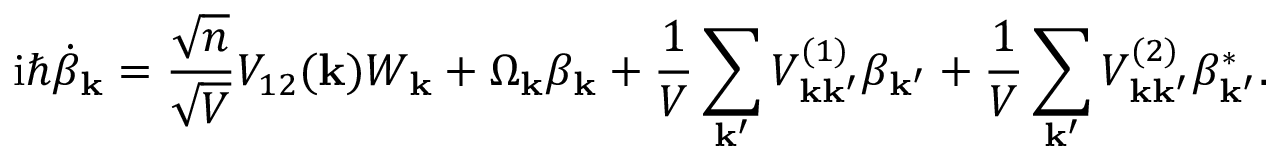Convert formula to latex. <formula><loc_0><loc_0><loc_500><loc_500>i \hbar { \dot } { \beta } _ { k } = \frac { \sqrt { n } } { \sqrt { V } } V _ { 1 2 } ( k ) W _ { k } + \Omega _ { k } \beta _ { k } + \frac { 1 } { V } \sum _ { k ^ { \prime } } V _ { k k ^ { \prime } } ^ { ( 1 ) } \beta _ { k ^ { \prime } } + \frac { 1 } { V } \sum _ { k ^ { \prime } } V _ { k k ^ { \prime } } ^ { ( 2 ) } \beta _ { k ^ { \prime } } ^ { * } .</formula> 